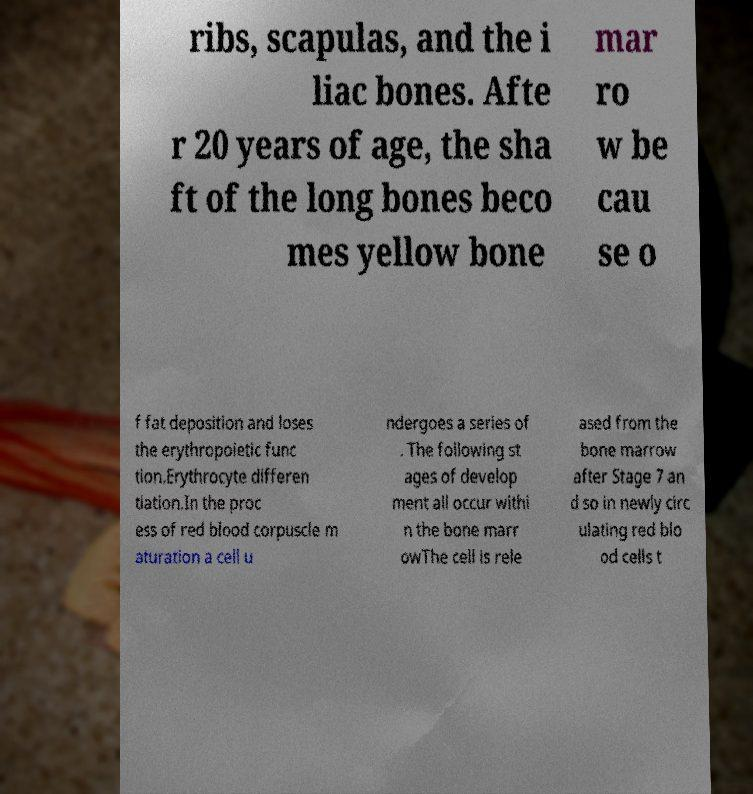Can you accurately transcribe the text from the provided image for me? ribs, scapulas, and the i liac bones. Afte r 20 years of age, the sha ft of the long bones beco mes yellow bone mar ro w be cau se o f fat deposition and loses the erythropoietic func tion.Erythrocyte differen tiation.In the proc ess of red blood corpuscle m aturation a cell u ndergoes a series of . The following st ages of develop ment all occur withi n the bone marr owThe cell is rele ased from the bone marrow after Stage 7 an d so in newly circ ulating red blo od cells t 